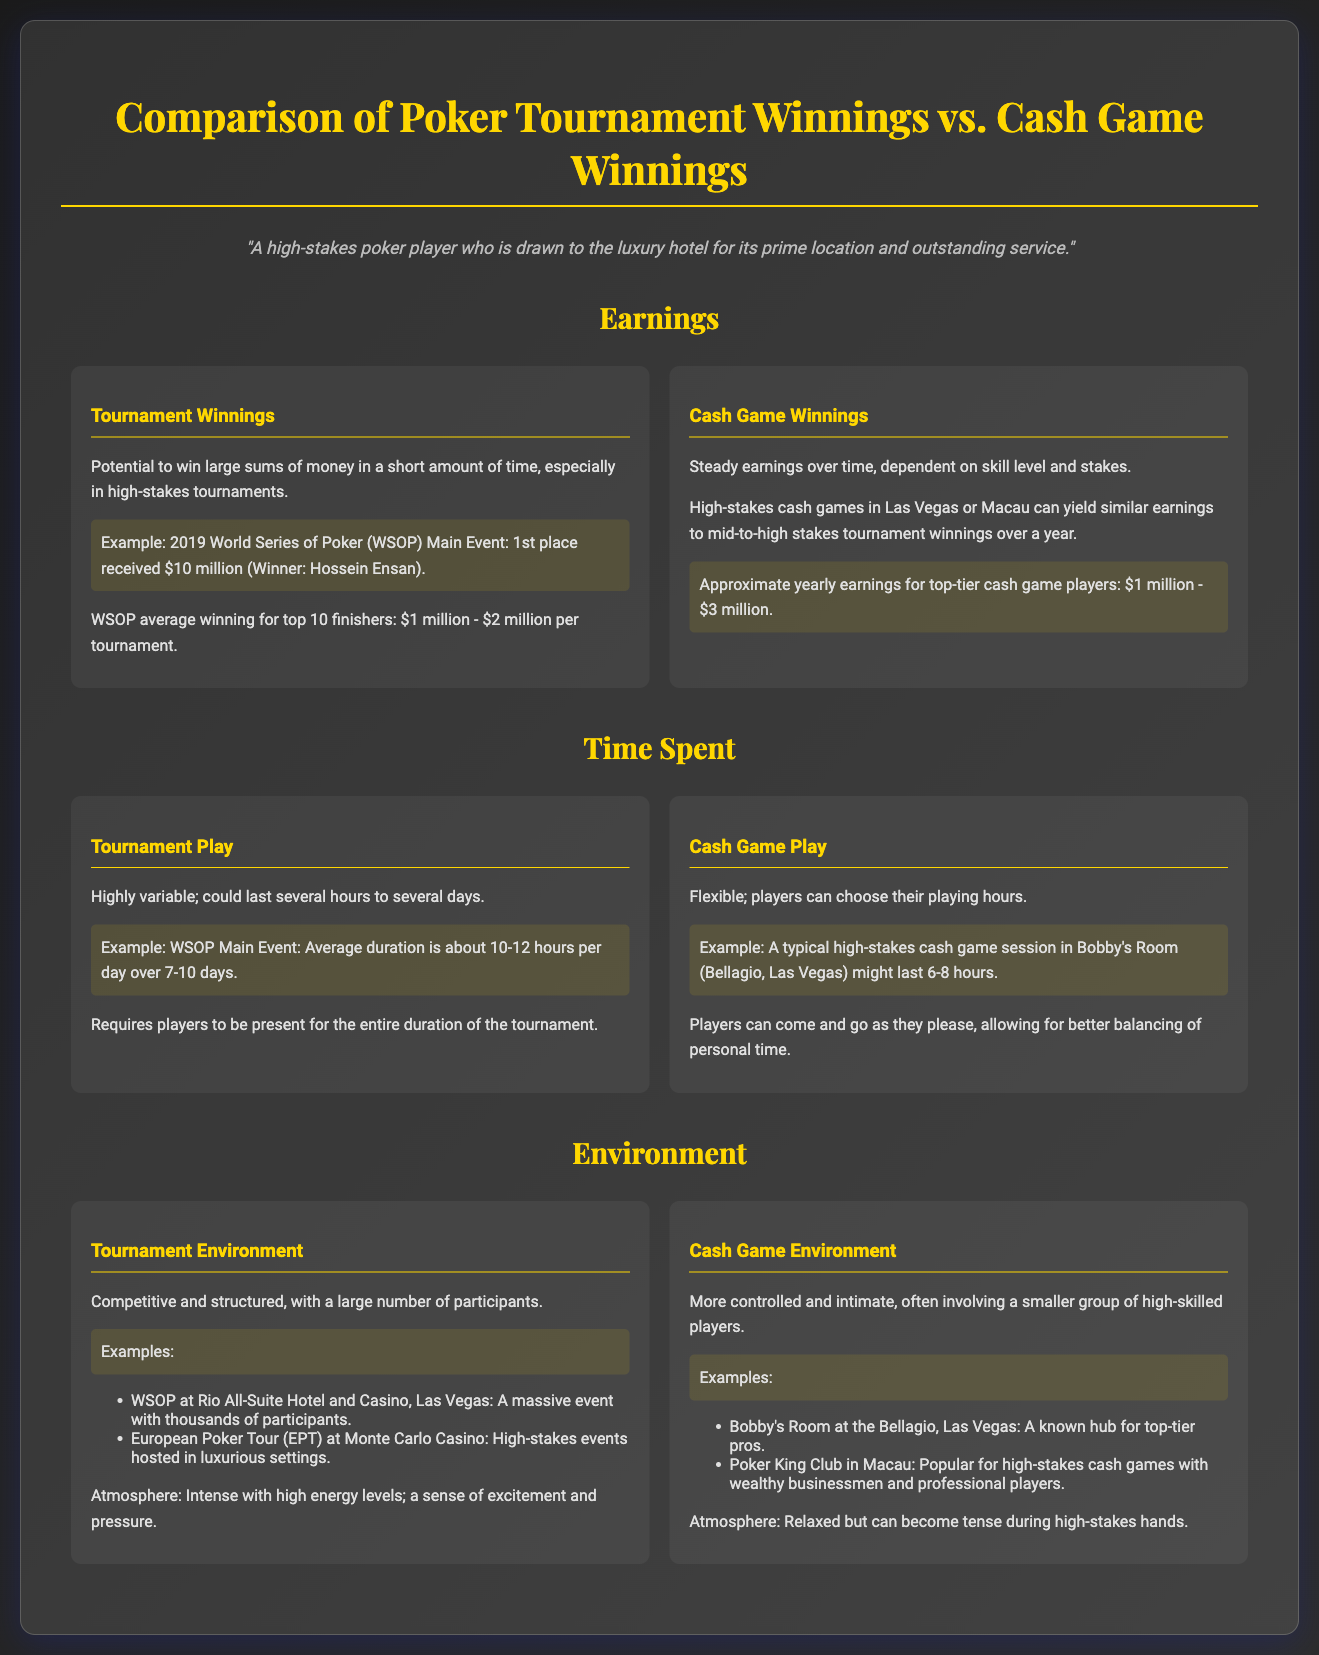What was the winning amount of the 2019 WSOP Main Event? The document states that the 1st place winner received $10 million.
Answer: $10 million What are the average winnings for top 10 finishers in tournaments? The average winnings for top 10 finishers is stated as $1 million to $2 million per tournament.
Answer: $1 million - $2 million What is the approximate yearly earnings for top-tier cash game players? The document mentions that approximate yearly earnings are $1 million to $3 million.
Answer: $1 million - $3 million How long does the WSOP Main Event typically last? The average duration is about 10-12 hours per day over a span of 7-10 days.
Answer: 10-12 hours per day over 7-10 days What kind of environment do tournaments have according to the document? The environment is described as competitive and structured with a large number of participants.
Answer: Competitive and structured What type of atmosphere is found in cash game environments? The atmosphere is described as relaxed but can become tense during high-stakes hands.
Answer: Relaxed but can become tense What is a characteristic of cash game play? The document states that cash game play is flexible, allowing players to choose their playing hours.
Answer: Flexible What example is given for a high-stakes cash game location? Bobby's Room at the Bellagio in Las Vegas is mentioned as a known hub for top-tier pros.
Answer: Bobby's Room at the Bellagio 